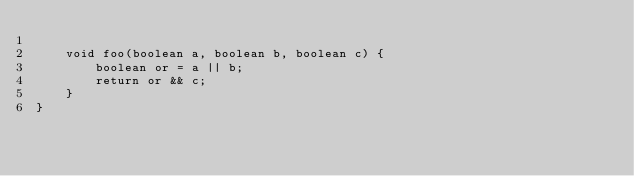<code> <loc_0><loc_0><loc_500><loc_500><_Java_>
    void foo(boolean a, boolean b, boolean c) {
        boolean or = a || b;
        return or && c;
    }
}
</code> 